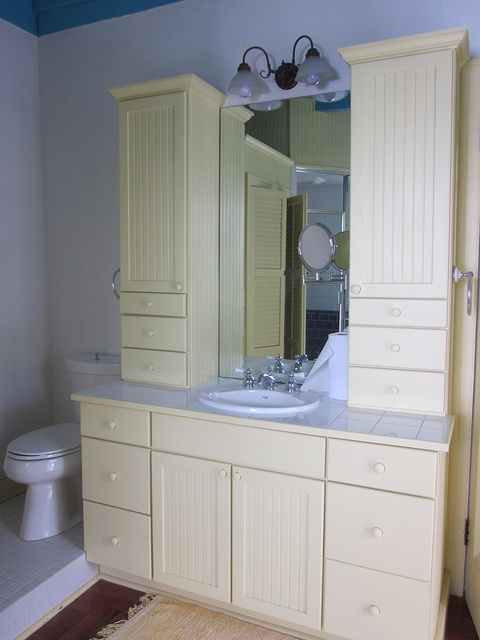Describe the objects in this image and their specific colors. I can see toilet in darkblue, gray, darkgray, and black tones and sink in darkblue, darkgray, and lavender tones in this image. 